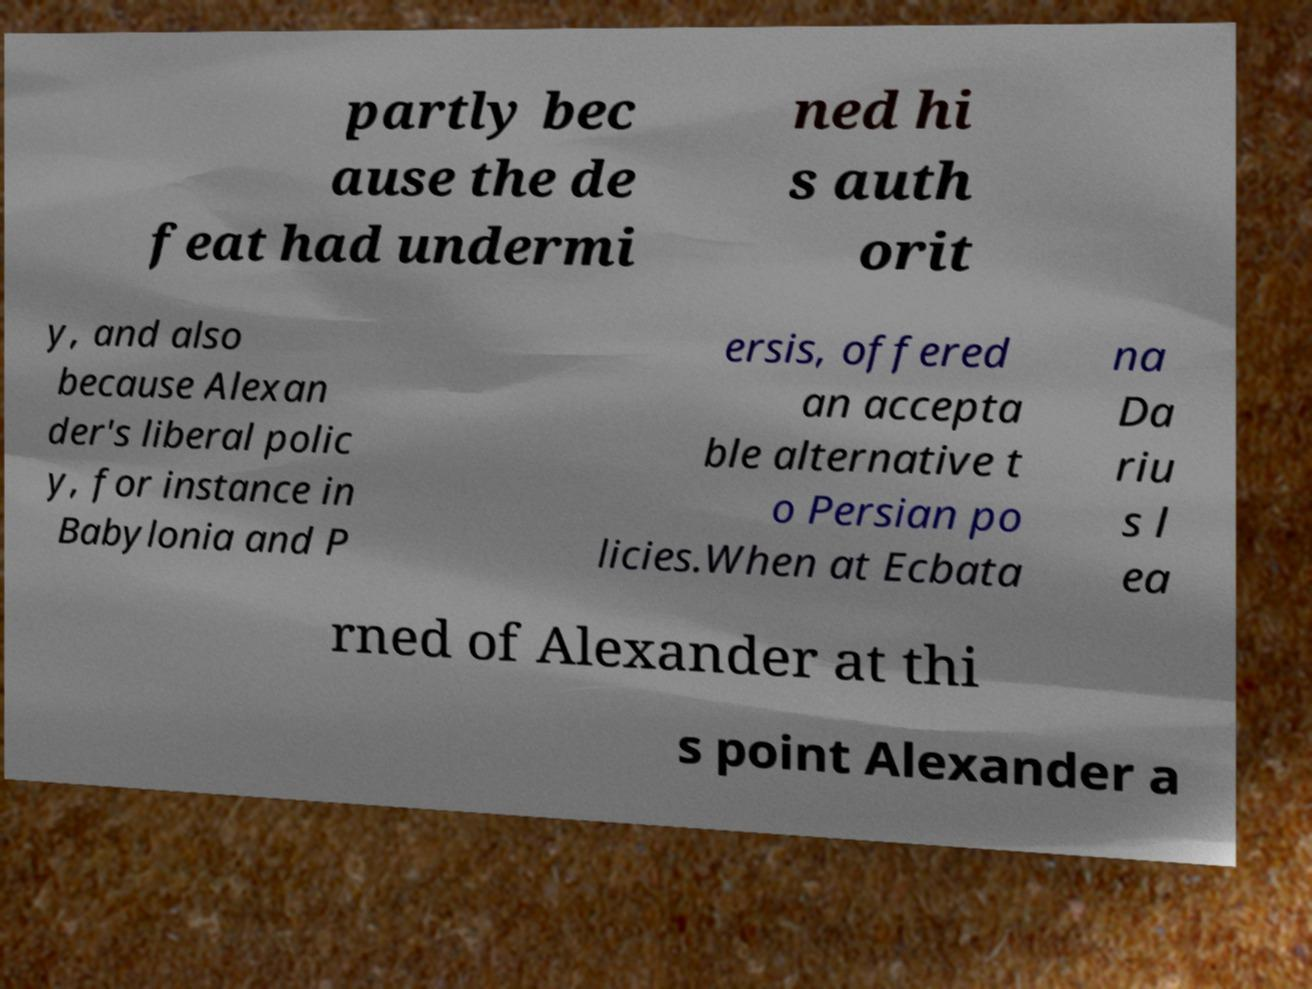Can you read and provide the text displayed in the image?This photo seems to have some interesting text. Can you extract and type it out for me? partly bec ause the de feat had undermi ned hi s auth orit y, and also because Alexan der's liberal polic y, for instance in Babylonia and P ersis, offered an accepta ble alternative t o Persian po licies.When at Ecbata na Da riu s l ea rned of Alexander at thi s point Alexander a 